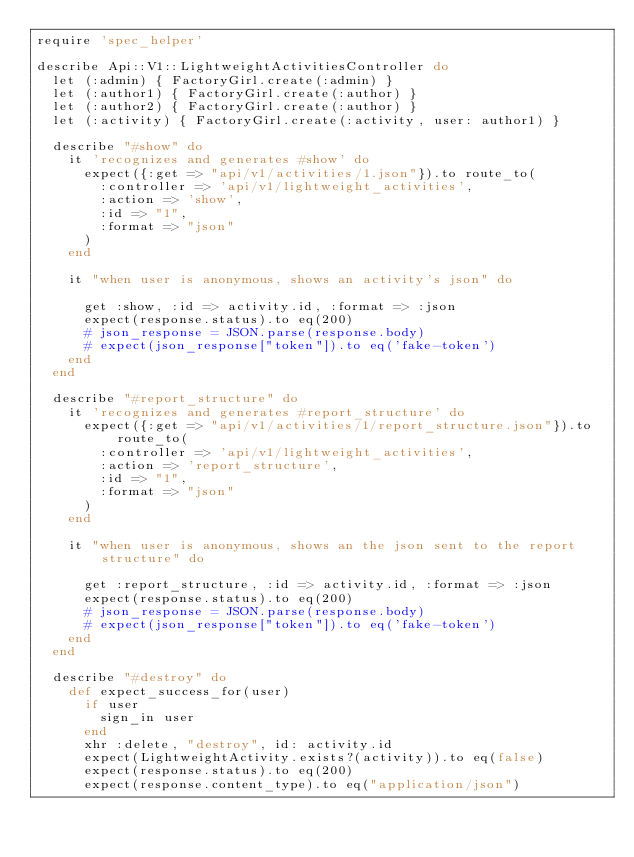<code> <loc_0><loc_0><loc_500><loc_500><_Ruby_>require 'spec_helper'

describe Api::V1::LightweightActivitiesController do
  let (:admin) { FactoryGirl.create(:admin) }
  let (:author1) { FactoryGirl.create(:author) }
  let (:author2) { FactoryGirl.create(:author) }
  let (:activity) { FactoryGirl.create(:activity, user: author1) }

  describe "#show" do
    it 'recognizes and generates #show' do
      expect({:get => "api/v1/activities/1.json"}).to route_to(
        :controller => 'api/v1/lightweight_activities',
        :action => 'show',
        :id => "1",
        :format => "json"
      )
    end

    it "when user is anonymous, shows an activity's json" do

      get :show, :id => activity.id, :format => :json
      expect(response.status).to eq(200)
      # json_response = JSON.parse(response.body)
      # expect(json_response["token"]).to eq('fake-token')
    end
  end

  describe "#report_structure" do
    it 'recognizes and generates #report_structure' do
      expect({:get => "api/v1/activities/1/report_structure.json"}).to route_to(
        :controller => 'api/v1/lightweight_activities',
        :action => 'report_structure',
        :id => "1",
        :format => "json"
      )
    end

    it "when user is anonymous, shows an the json sent to the report structure" do

      get :report_structure, :id => activity.id, :format => :json
      expect(response.status).to eq(200)
      # json_response = JSON.parse(response.body)
      # expect(json_response["token"]).to eq('fake-token')
    end
  end

  describe "#destroy" do
    def expect_success_for(user)
      if user
        sign_in user
      end
      xhr :delete, "destroy", id: activity.id
      expect(LightweightActivity.exists?(activity)).to eq(false)
      expect(response.status).to eq(200)
      expect(response.content_type).to eq("application/json")</code> 